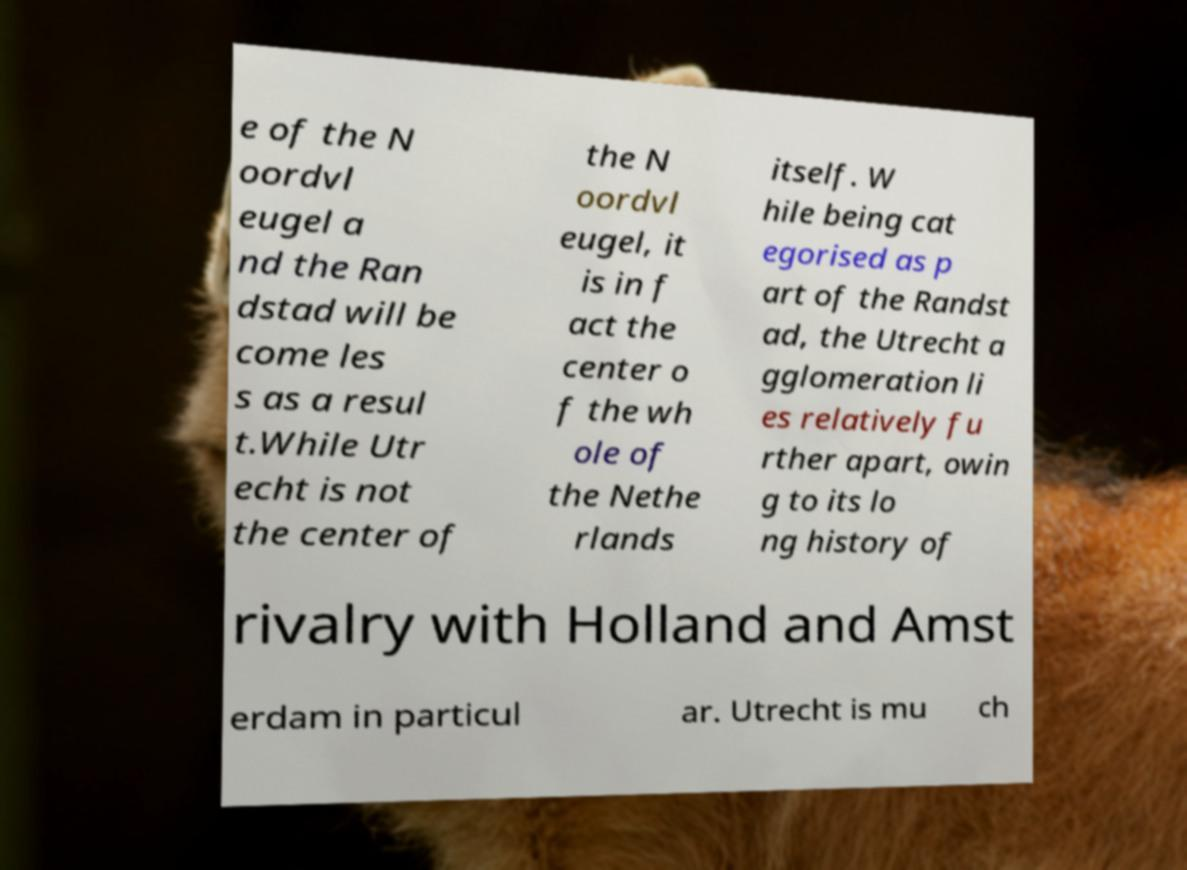Please read and relay the text visible in this image. What does it say? e of the N oordvl eugel a nd the Ran dstad will be come les s as a resul t.While Utr echt is not the center of the N oordvl eugel, it is in f act the center o f the wh ole of the Nethe rlands itself. W hile being cat egorised as p art of the Randst ad, the Utrecht a gglomeration li es relatively fu rther apart, owin g to its lo ng history of rivalry with Holland and Amst erdam in particul ar. Utrecht is mu ch 